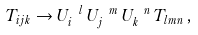<formula> <loc_0><loc_0><loc_500><loc_500>T _ { i j k } \rightarrow U _ { i } ^ { \ l } \, U _ { j } ^ { \ m } \, U _ { k } ^ { \ n } \, T _ { l m n } \, ,</formula> 